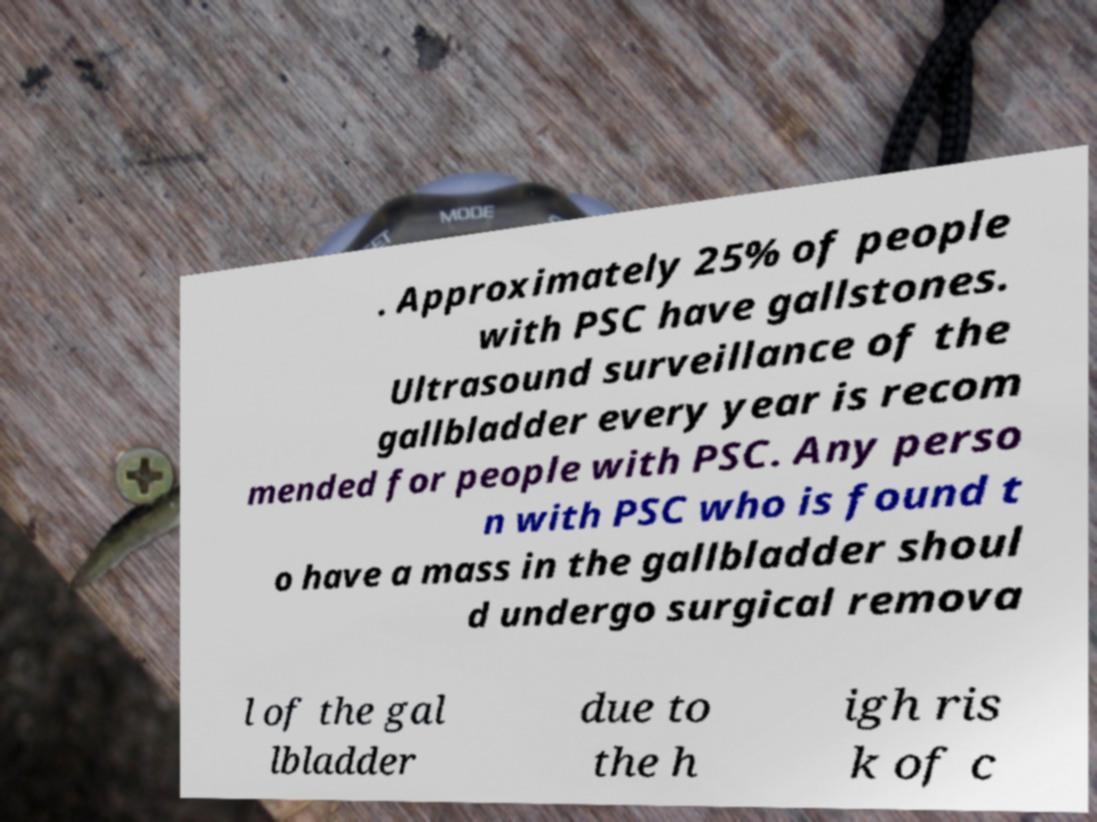Please read and relay the text visible in this image. What does it say? . Approximately 25% of people with PSC have gallstones. Ultrasound surveillance of the gallbladder every year is recom mended for people with PSC. Any perso n with PSC who is found t o have a mass in the gallbladder shoul d undergo surgical remova l of the gal lbladder due to the h igh ris k of c 